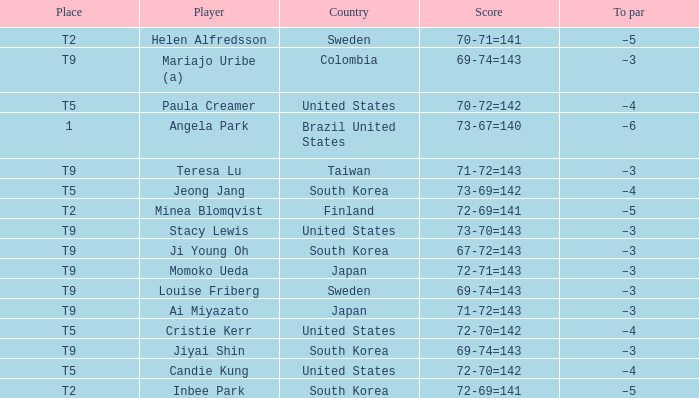Who scored 69-74=143 for Colombia? Mariajo Uribe (a). 